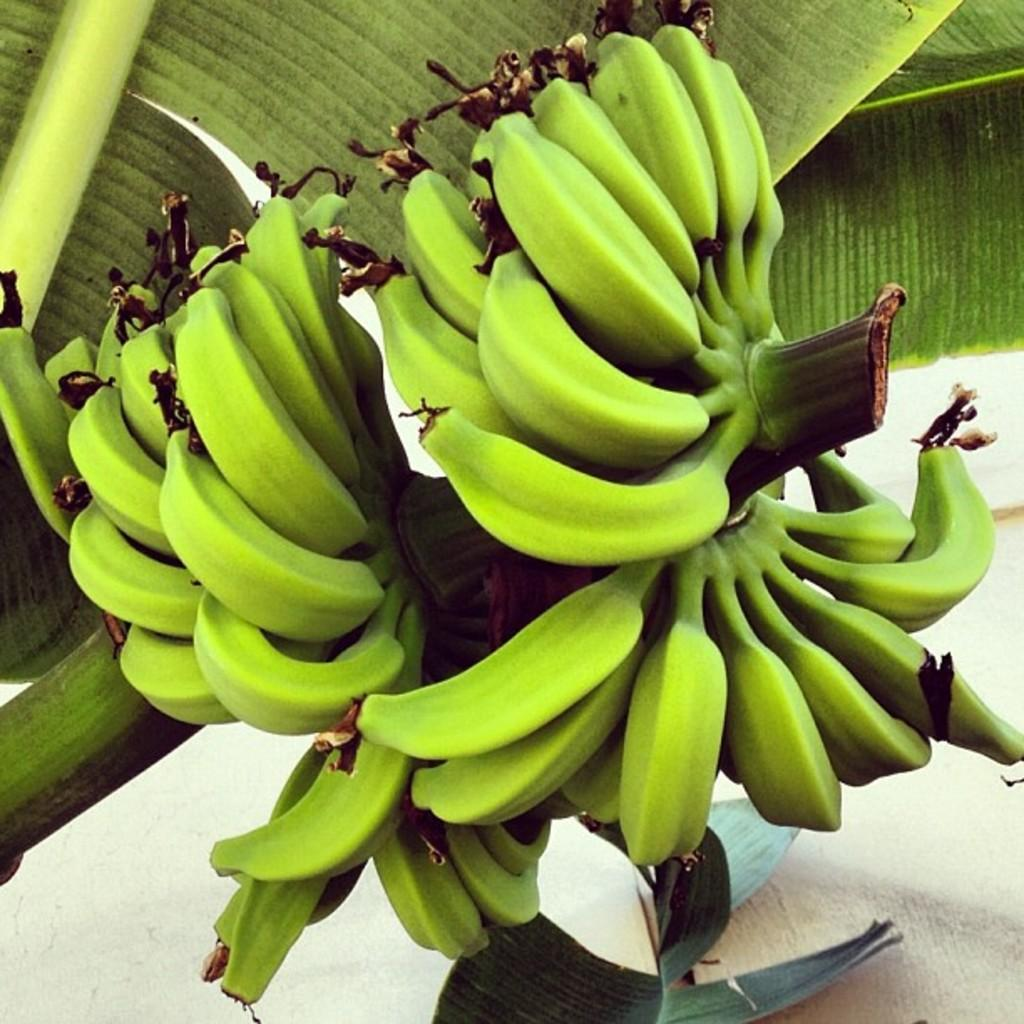What type of fruit is visible in the image? There is a bunch of bananas in the image. What is the color of the bananas? The bananas are green. What other plant-related items can be seen in the image? There are leaves in the image. What is the color of the leaves? The leaves are green. Can you hear the sound of thunder in the image? There is no sound present in the image, so it is not possible to hear thunder. 